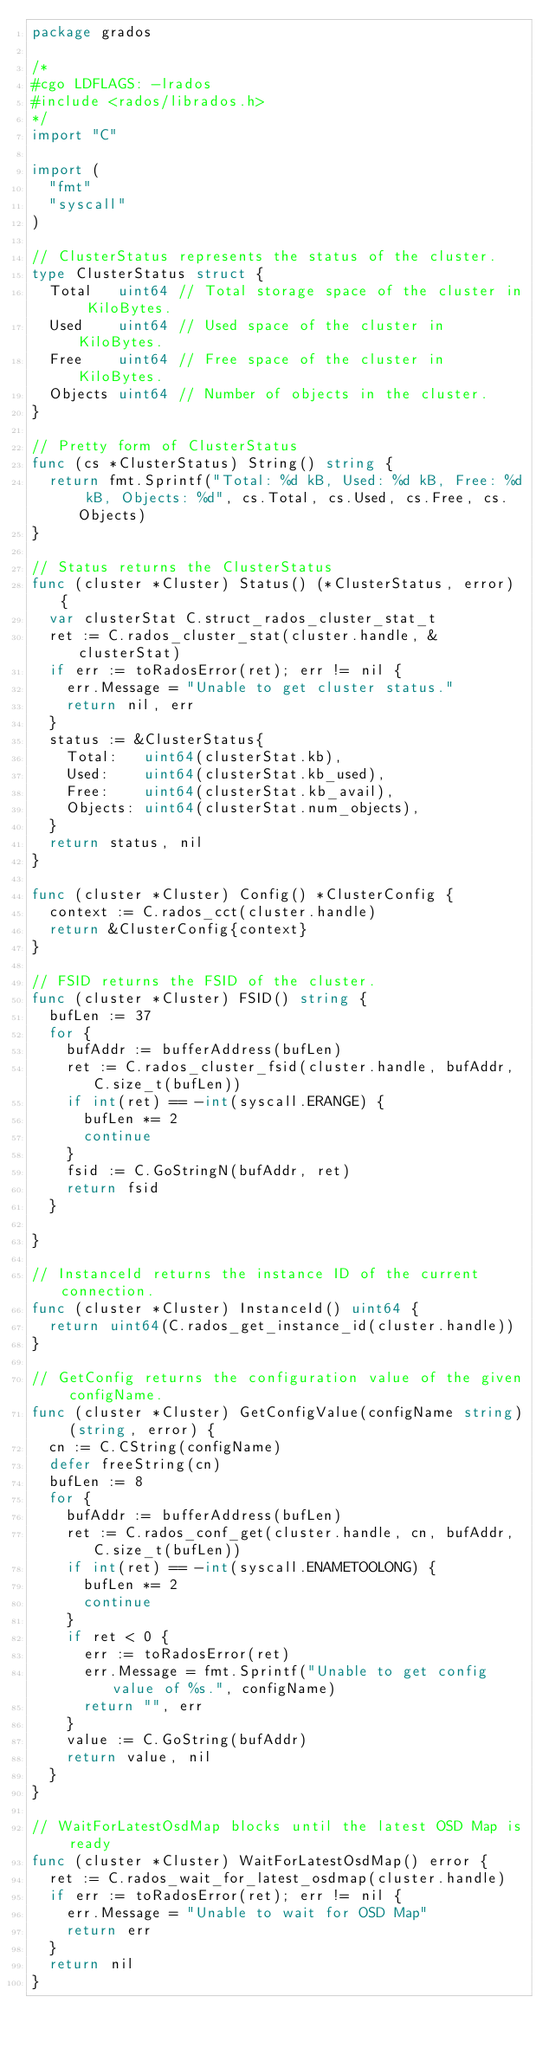Convert code to text. <code><loc_0><loc_0><loc_500><loc_500><_Go_>package grados

/*
#cgo LDFLAGS: -lrados
#include <rados/librados.h>
*/
import "C"

import (
	"fmt"
	"syscall"
)

// ClusterStatus represents the status of the cluster.
type ClusterStatus struct {
	Total   uint64 // Total storage space of the cluster in KiloBytes.
	Used    uint64 // Used space of the cluster in KiloBytes.
	Free    uint64 // Free space of the cluster in KiloBytes.
	Objects uint64 // Number of objects in the cluster.
}

// Pretty form of ClusterStatus
func (cs *ClusterStatus) String() string {
	return fmt.Sprintf("Total: %d kB, Used: %d kB, Free: %d kB, Objects: %d", cs.Total, cs.Used, cs.Free, cs.Objects)
}

// Status returns the ClusterStatus
func (cluster *Cluster) Status() (*ClusterStatus, error) {
	var clusterStat C.struct_rados_cluster_stat_t
	ret := C.rados_cluster_stat(cluster.handle, &clusterStat)
	if err := toRadosError(ret); err != nil {
		err.Message = "Unable to get cluster status."
		return nil, err
	}
	status := &ClusterStatus{
		Total:   uint64(clusterStat.kb),
		Used:    uint64(clusterStat.kb_used),
		Free:    uint64(clusterStat.kb_avail),
		Objects: uint64(clusterStat.num_objects),
	}
	return status, nil
}

func (cluster *Cluster) Config() *ClusterConfig {
	context := C.rados_cct(cluster.handle)
	return &ClusterConfig{context}
}

// FSID returns the FSID of the cluster.
func (cluster *Cluster) FSID() string {
	bufLen := 37
	for {
		bufAddr := bufferAddress(bufLen)
		ret := C.rados_cluster_fsid(cluster.handle, bufAddr, C.size_t(bufLen))
		if int(ret) == -int(syscall.ERANGE) {
			bufLen *= 2
			continue
		}
		fsid := C.GoStringN(bufAddr, ret)
		return fsid
	}

}

// InstanceId returns the instance ID of the current connection.
func (cluster *Cluster) InstanceId() uint64 {
	return uint64(C.rados_get_instance_id(cluster.handle))
}

// GetConfig returns the configuration value of the given configName.
func (cluster *Cluster) GetConfigValue(configName string) (string, error) {
	cn := C.CString(configName)
	defer freeString(cn)
	bufLen := 8
	for {
		bufAddr := bufferAddress(bufLen)
		ret := C.rados_conf_get(cluster.handle, cn, bufAddr, C.size_t(bufLen))
		if int(ret) == -int(syscall.ENAMETOOLONG) {
			bufLen *= 2
			continue
		}
		if ret < 0 {
			err := toRadosError(ret)
			err.Message = fmt.Sprintf("Unable to get config value of %s.", configName)
			return "", err
		}
		value := C.GoString(bufAddr)
		return value, nil
	}
}

// WaitForLatestOsdMap blocks until the latest OSD Map is ready
func (cluster *Cluster) WaitForLatestOsdMap() error {
	ret := C.rados_wait_for_latest_osdmap(cluster.handle)
	if err := toRadosError(ret); err != nil {
		err.Message = "Unable to wait for OSD Map"
		return err
	}
	return nil
}
</code> 